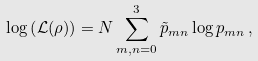Convert formula to latex. <formula><loc_0><loc_0><loc_500><loc_500>\log \left ( \mathcal { L } ( \rho ) \right ) = N \sum _ { m , n = 0 } ^ { 3 } \tilde { p } _ { m n } \log p _ { m n } \, ,</formula> 